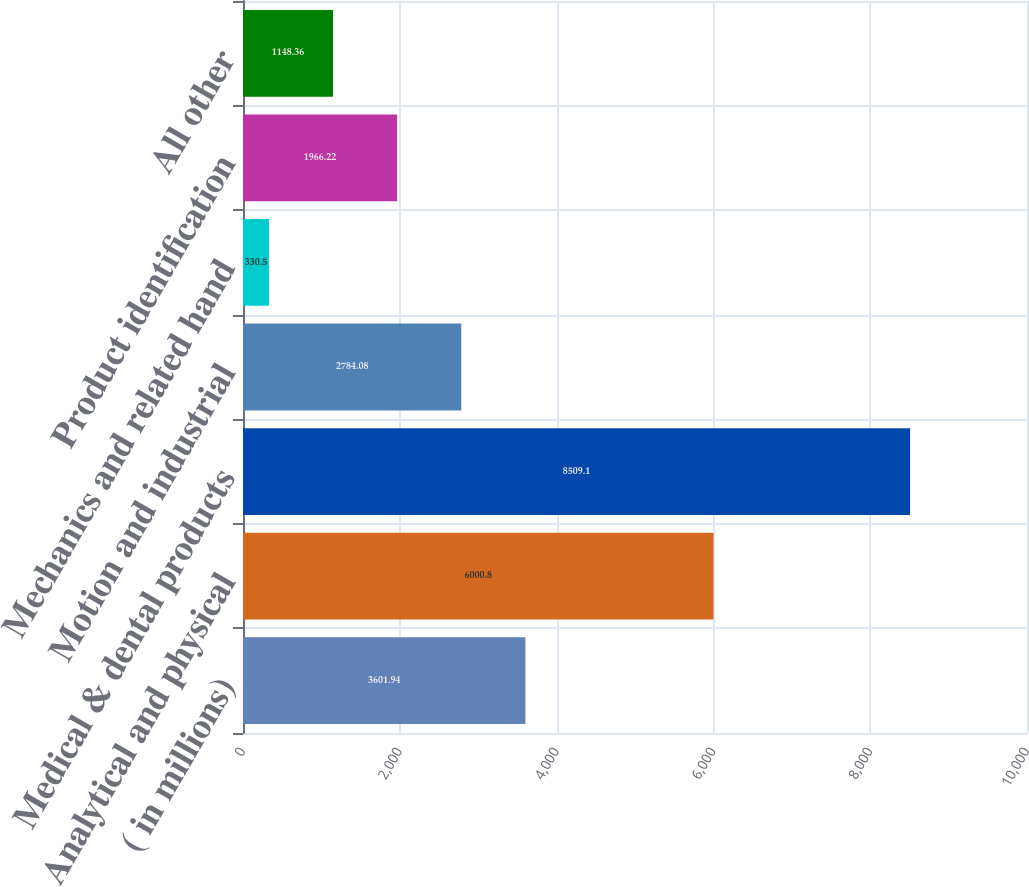<chart> <loc_0><loc_0><loc_500><loc_500><bar_chart><fcel>( in millions)<fcel>Analytical and physical<fcel>Medical & dental products<fcel>Motion and industrial<fcel>Mechanics and related hand<fcel>Product identification<fcel>All other<nl><fcel>3601.94<fcel>6000.8<fcel>8509.1<fcel>2784.08<fcel>330.5<fcel>1966.22<fcel>1148.36<nl></chart> 